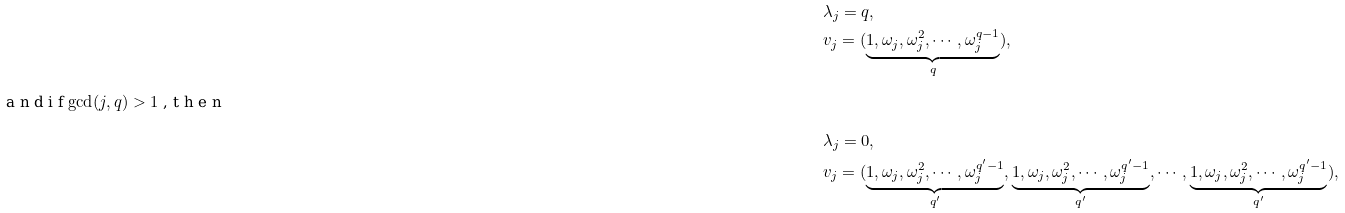<formula> <loc_0><loc_0><loc_500><loc_500>& \lambda _ { j } = q , \\ & v _ { j } = ( \underbrace { 1 , \omega _ { j } , \omega _ { j } ^ { 2 } , \cdots , \omega _ { j } ^ { q - 1 } } _ { q } ) , \intertext { a n d i f $ \gcd ( j , q ) > 1 $ , t h e n } & \lambda _ { j } = 0 , \\ & v _ { j } = ( \underbrace { 1 , \omega _ { j } , \omega _ { j } ^ { 2 } , \cdots , \omega _ { j } ^ { q ^ { \prime } - 1 } } _ { q ^ { \prime } } , \underbrace { 1 , \omega _ { j } , \omega _ { j } ^ { 2 } , \cdots , \omega _ { j } ^ { q ^ { \prime } - 1 } } _ { q ^ { \prime } } , \cdots , \underbrace { 1 , \omega _ { j } , \omega _ { j } ^ { 2 } , \cdots , \omega _ { j } ^ { q ^ { \prime } - 1 } } _ { q ^ { \prime } } ) ,</formula> 